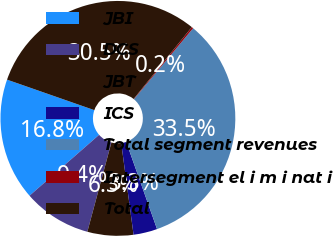Convert chart to OTSL. <chart><loc_0><loc_0><loc_500><loc_500><pie_chart><fcel>JBI<fcel>DCS<fcel>JBT<fcel>ICS<fcel>Total segment revenues<fcel>Intersegment el i m i nat i<fcel>Total<nl><fcel>16.79%<fcel>9.37%<fcel>6.32%<fcel>3.28%<fcel>33.53%<fcel>0.23%<fcel>30.48%<nl></chart> 